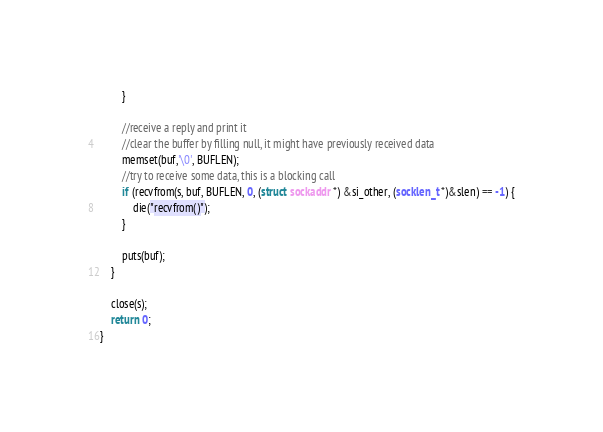Convert code to text. <code><loc_0><loc_0><loc_500><loc_500><_C++_>		}
         
		//receive a reply and print it
		//clear the buffer by filling null, it might have previously received data
		memset(buf,'\0', BUFLEN);
		//try to receive some data, this is a blocking call
		if (recvfrom(s, buf, BUFLEN, 0, (struct sockaddr *) &si_other, (socklen_t *)&slen) == -1) {
			die("recvfrom()");
		}
         
		puts(buf);
	}
 
	close(s);
	return 0;
}
</code> 